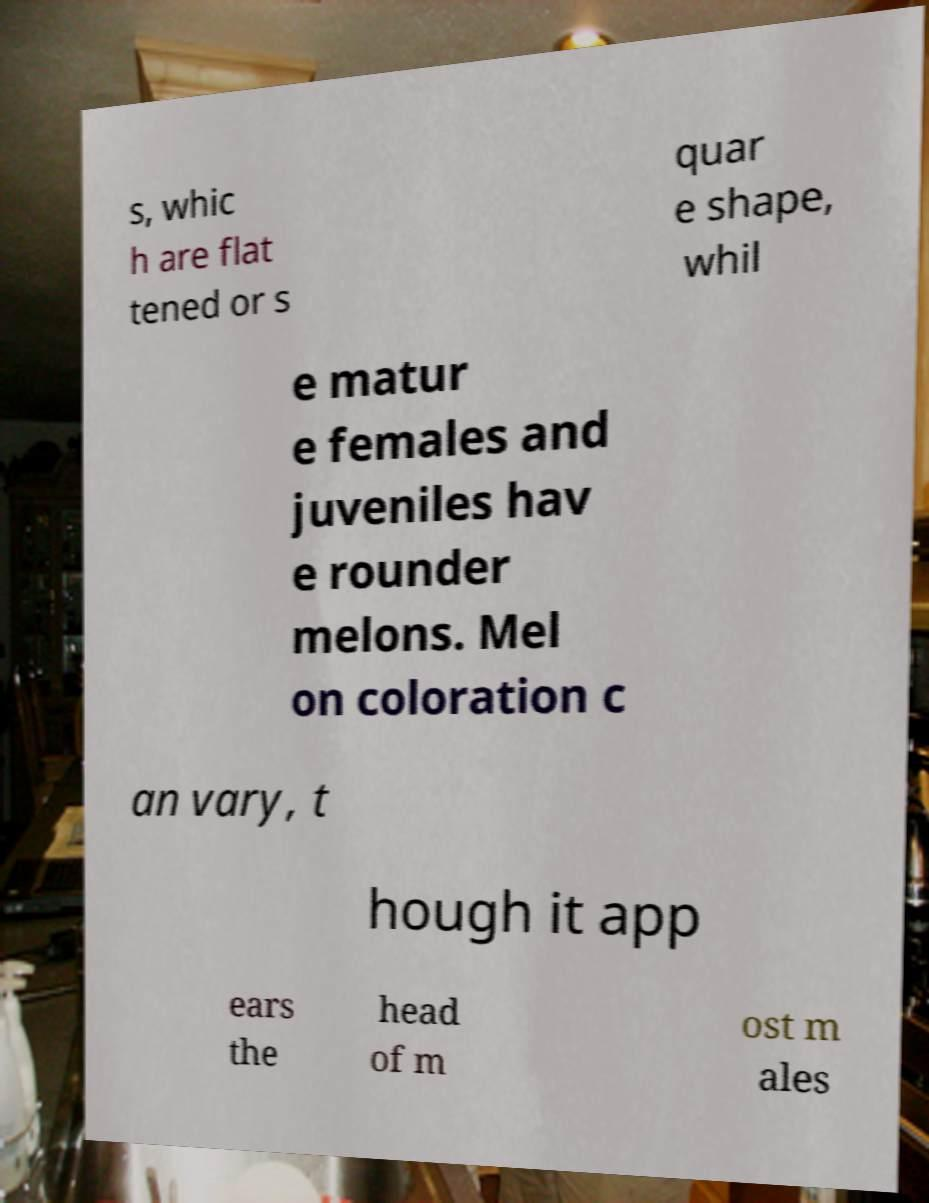For documentation purposes, I need the text within this image transcribed. Could you provide that? s, whic h are flat tened or s quar e shape, whil e matur e females and juveniles hav e rounder melons. Mel on coloration c an vary, t hough it app ears the head of m ost m ales 